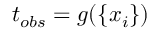Convert formula to latex. <formula><loc_0><loc_0><loc_500><loc_500>t _ { o b s } = g ( \{ x _ { i } \} )</formula> 